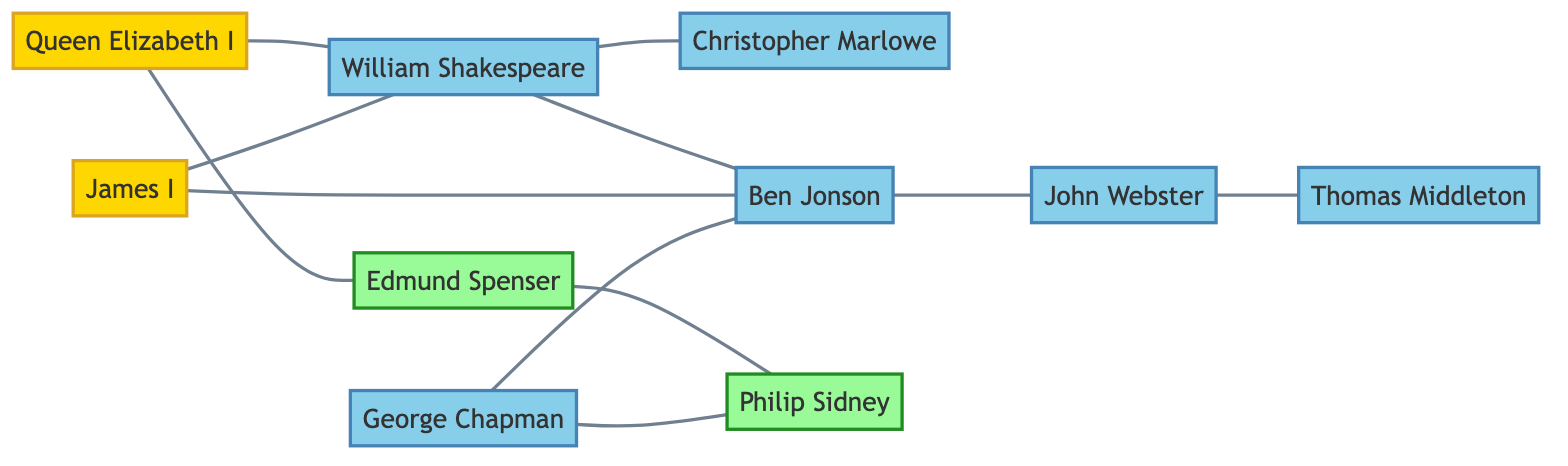What is the total number of literary figures represented in this diagram? The diagram lists ten nodes, each representing a distinct literary figure. Therefore, the total number of literary figures is simply the count of these nodes.
Answer: 10 Which monarch is directly connected to William Shakespeare? The diagram has a direct edge between the node representing Queen Elizabeth I and the node representing William Shakespeare, indicating a direct connection.
Answer: Queen Elizabeth I How many connections (edges) are associated with Ben Jonson? By examining the edges connected to the Ben Jonson node, we find that there are four direct connections leading to other nodes. Thus, the number of edges associated with Ben Jonson can be counted directly from the diagram.
Answer: 4 Which poet is connected to both Edmund Spenser and George Chapman? Reviewing the connections emanating from George Chapman reveals a connection to Philip Sidney, as he is the only poet linked to both George Chapman and Edmund Spenser in the diagram.
Answer: Philip Sidney Who is connected to both John Webster and Thomas Middleton? The edges in the diagram show a direct connection between John Webster and Thomas Middleton, indicating that these two figures are directly linked through an edge; thus, the answer is a straightforward reference to John Webster.
Answer: John Webster 